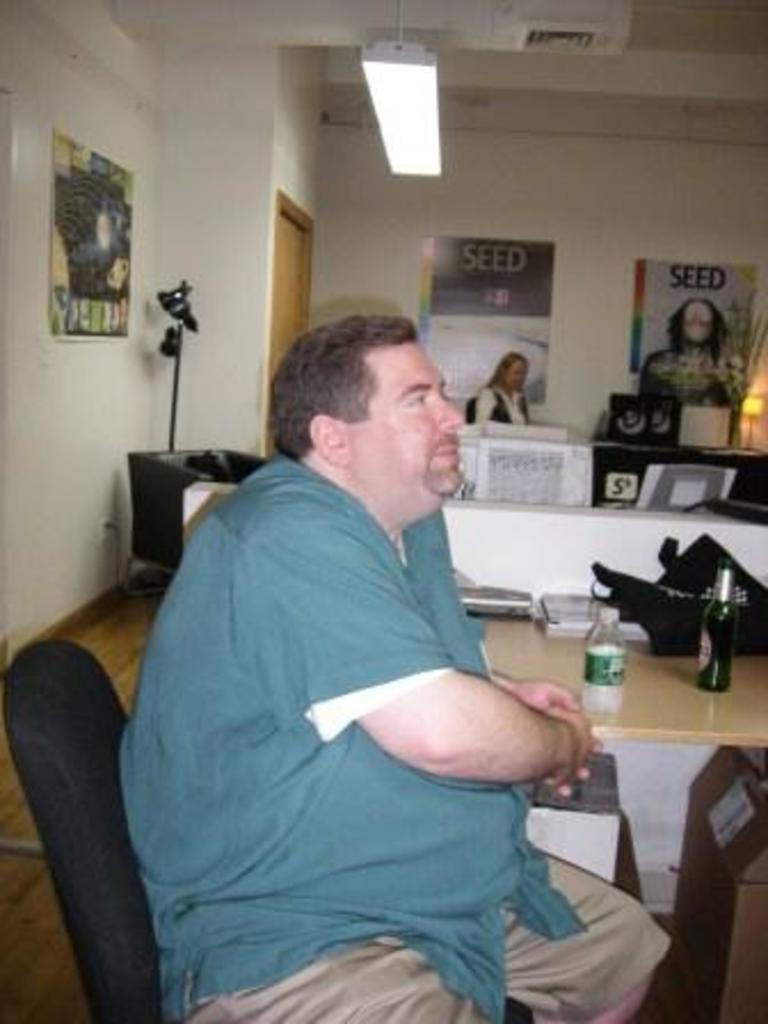In one or two sentences, can you explain what this image depicts? In this picture a man is seated on the chair, next to him we can find bottles, books on the table, in the background we can see couple of wall posters on the wall, and also a woman, on top of them we can find a light. 